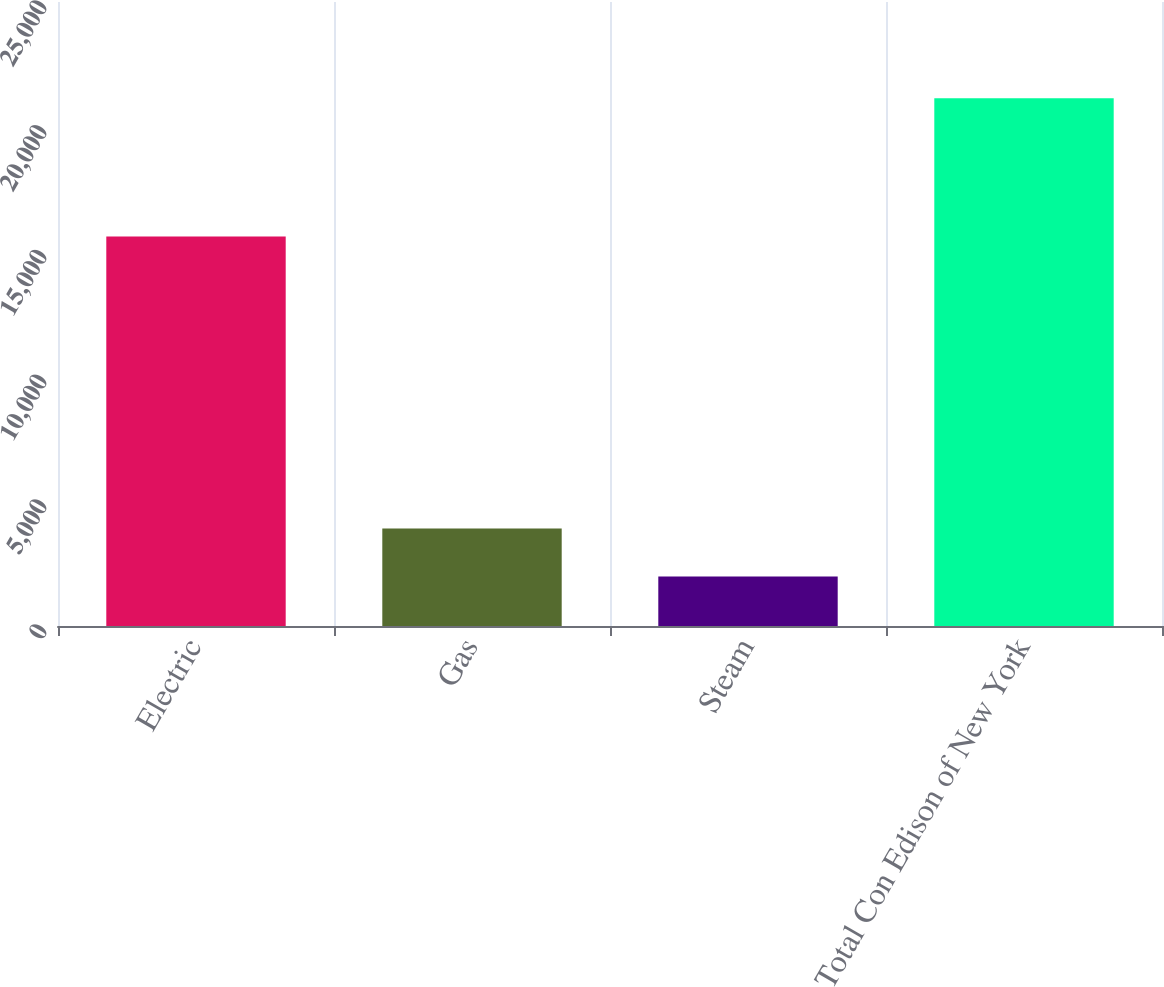<chart> <loc_0><loc_0><loc_500><loc_500><bar_chart><fcel>Electric<fcel>Gas<fcel>Steam<fcel>Total Con Edison of New York<nl><fcel>15609<fcel>3902<fcel>1986<fcel>21146<nl></chart> 